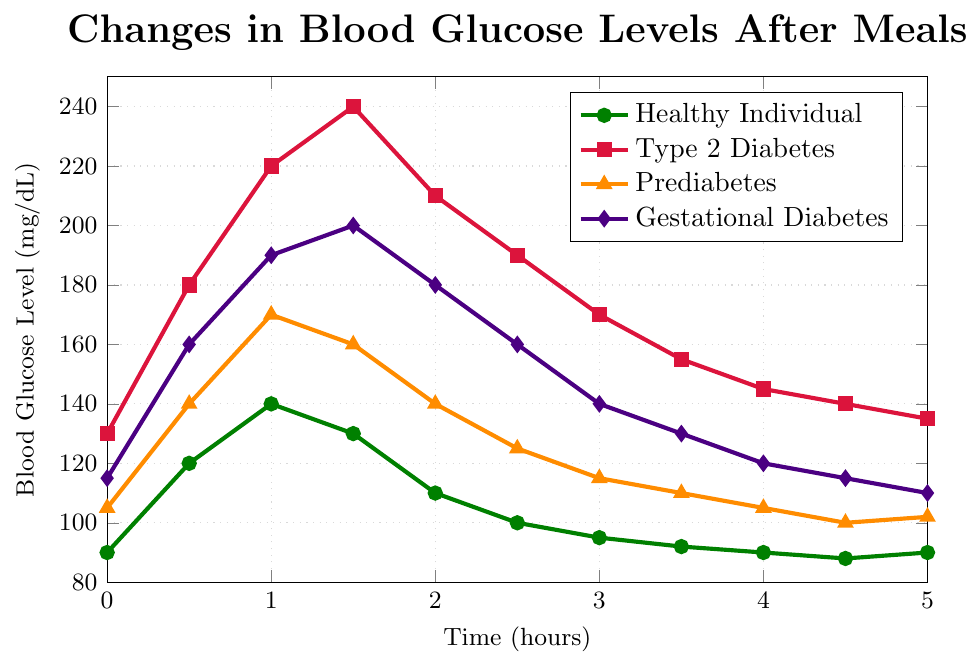What is the highest blood glucose level observed for a healthy individual? Look at the values plotted for the healthy individual category and identify the maximum value. The highest blood glucose level is at 1 hour, which is 140 mg/dL.
Answer: 140 mg/dL Which group experienced the most significant blood glucose level at the 1.5-hour mark? Compare the blood glucose levels of all groups at the 1.5-hour mark. Type 2 Diabetes has the highest value, which is 240 mg/dL.
Answer: Type 2 Diabetes By how much does the blood glucose level of a person with Type 2 Diabetes change from 1 hour to 3 hours? Subtract the value at 3 hours from the value at 1 hour for Type 2 Diabetes: 220 mg/dL at 1 hour minus 170 mg/dL at 3 hours equals a 50 mg/dL decrease.
Answer: 50 mg/dL Which condition shows the least variation in blood glucose level over the 5-hour period? Calculate the difference between the highest and lowest blood glucose level for each condition over the 5 hours and compare them. Healthy Individual: max 140, min 88 (difference 52). Type 2 Diabetes: max 240, min 130 (difference 110). Prediabetes: max 170, min 100 (difference 70). Gestational Diabetes: max 200, min 110 (difference 90). The Healthy Individual shows the least variation of 52 mg/dL.
Answer: Healthy Individual At which time do the blood glucose levels of individuals with Prediabetes and Gestational Diabetes intersect, if at all? Compare the plotted points for Prediabetes and Gestational Diabetes at each time mark. They intersect at 5 hours, both at approximately 110–112 mg/dL.
Answer: 5 hours What is the average blood glucose level for a healthy individual over the 5-hour period? Sum the values for the healthy individual and divide by the number of data points. (90 + 120 + 140 + 130 + 110 + 100 + 95 + 92 + 90 + 88 + 90) / 11 = 104.36 mg/dL
Answer: 104.36 mg/dL Which individual shows the fastest decline in blood glucose level from their peak level and in which timeframe? Identify the peak for each condition and calculate the decline rate to the lowest point, comparing their time duration to decline. Type 2 Diabetes peaks at 240 mg/dL and drops to 135 mg/dL over 4 hours, a drop of 105 mg/dL. Healthy Individual peaks at 140, dropping to 88 over 4 hours (52 mg/dL). Prediabetes peaks at 170 and drops to 102 over 4 hours (68 mg/dL). Gestational Diabetes peaks at 200 and drops to 110 over 4 hours (90 mg/dL). Type 2 Diabetes shows the fastest decline.
Answer: Type 2 Diabetes, 4 hours How much higher is the blood glucose level of individuals with Gestational Diabetes than those with Prediabetes 1 hour after the meal? Subtract the level for Prediabetes from Gestational Diabetes at 1 hour: 190 mg/dL (Gestational Diabetes) - 170 mg/dL (Prediabetes) = 20 mg/dL higher.
Answer: 20 mg/dL At the 2-hour mark, which group has a blood glucose level closest to that of a healthy individual? Compare the blood glucose levels at 2 hours: Healthy Individual: 110 mg/dL, Type 2 Diabetes: 210 mg/dL, Prediabetes: 140 mg/dL, Gestational Diabetes: 180 mg/dL. Prediabetes is closest to the healthy individual.
Answer: Prediabetes Which condition shows a blood glucose level closest to the starting level after 5 hours? Compare the blood glucose levels at 5 hours to the initial levels for each condition and check the differences. Healthy Individual: starts at 90, ends at 90 (difference 0). Type 2 Diabetes: starts at 130, ends at 135 (difference 5). Prediabetes: starts at 105, ends at 102 (difference 3). Gestational Diabetes: starts at 115, ends at 110 (difference 5). The Healthy Individual returns to their starting level.
Answer: Healthy Individual 